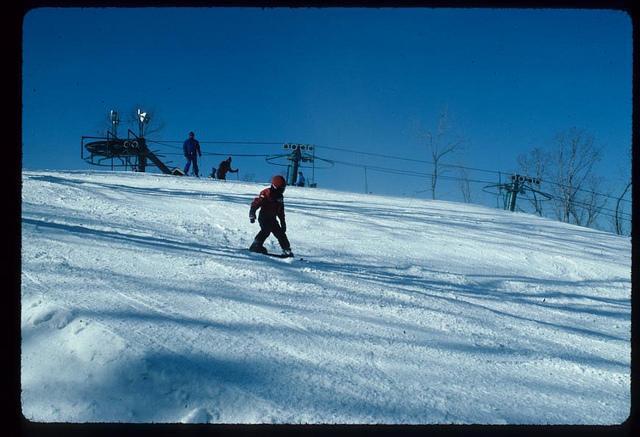How many brown bench seats?
Give a very brief answer. 0. 